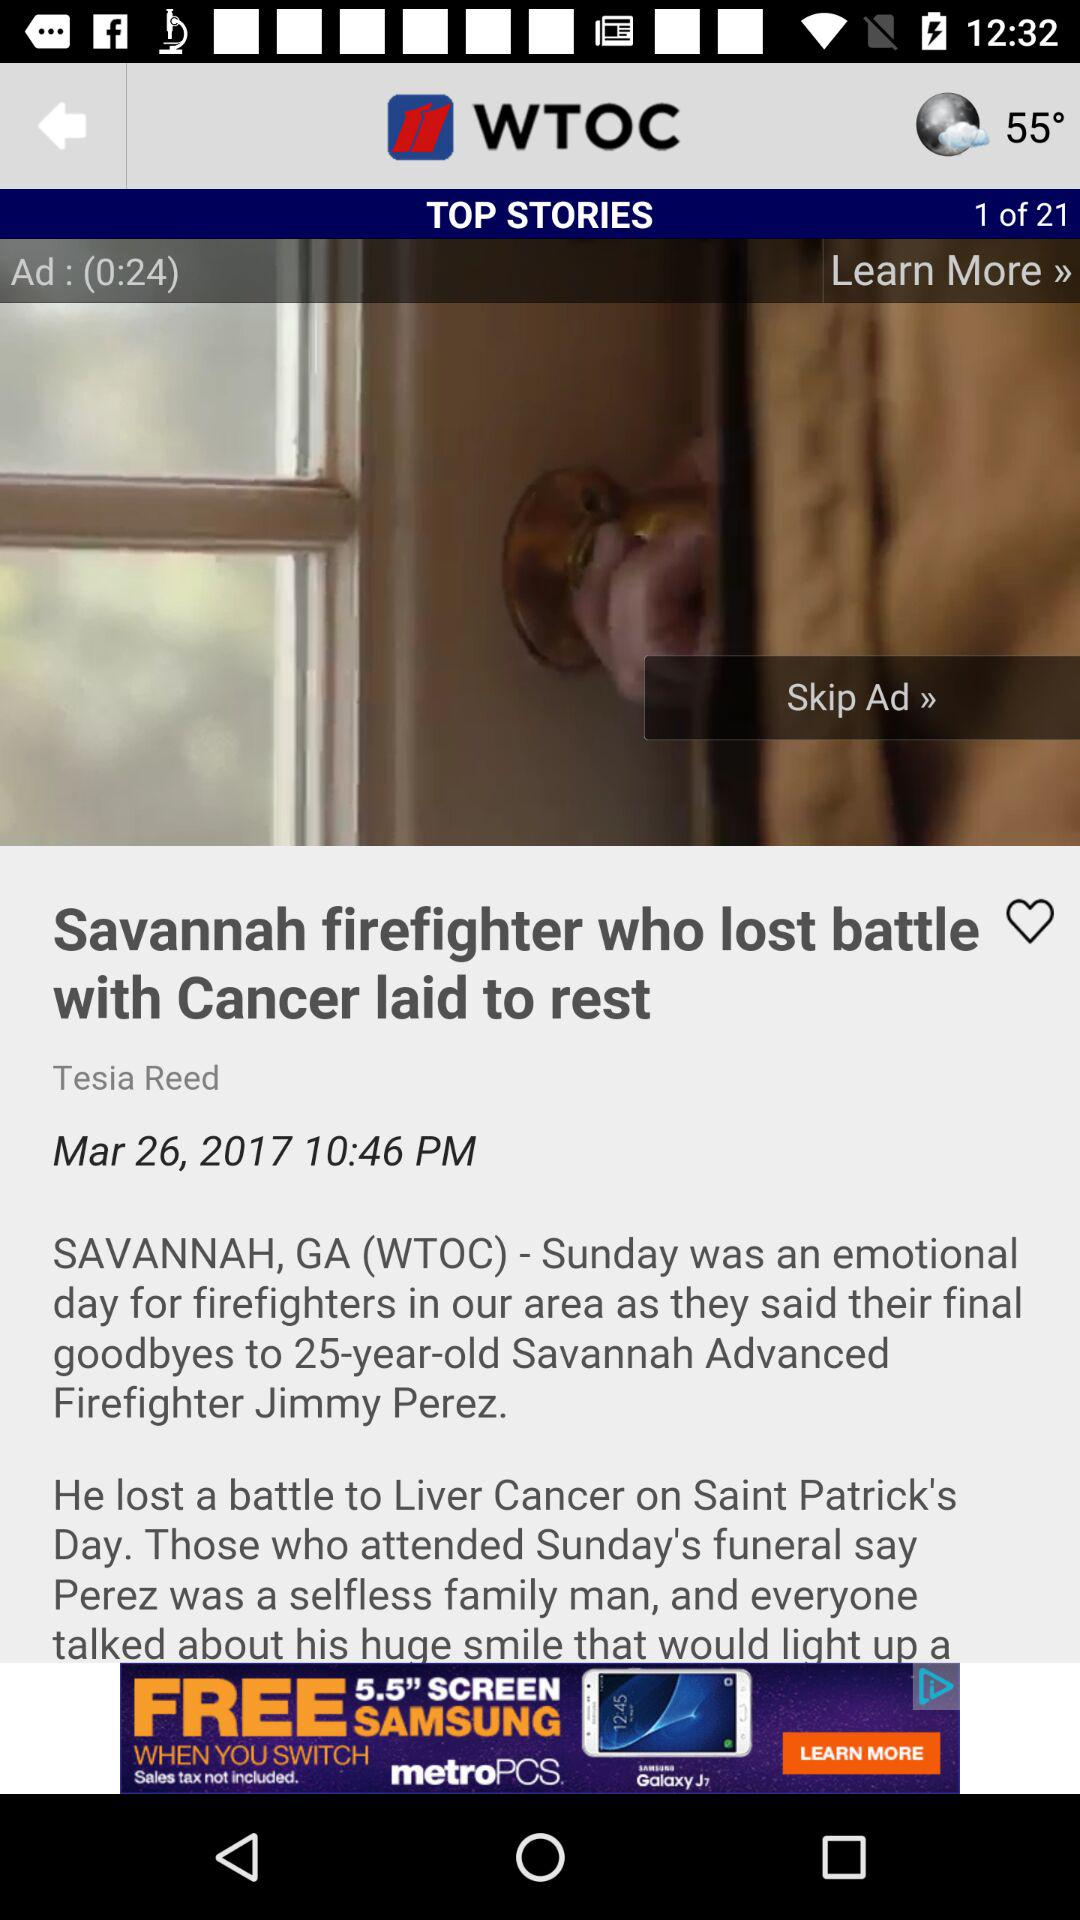When was the news "Savannah firefighter who lost battle with Cancer laid to rest" posted? The news was posted on March 26, 2017. 